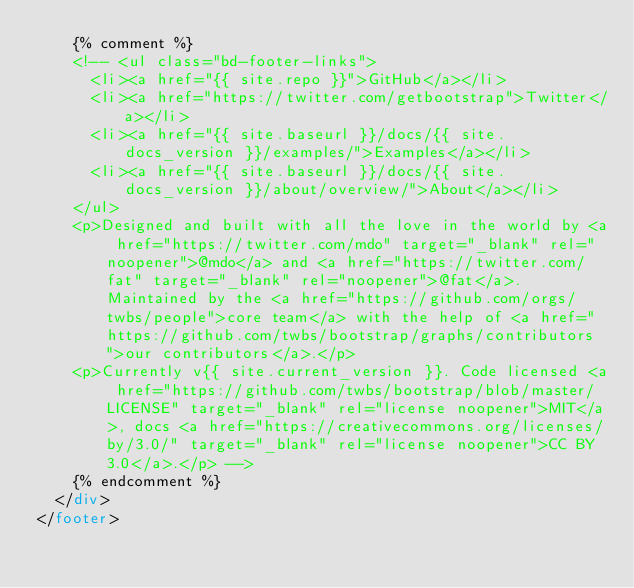<code> <loc_0><loc_0><loc_500><loc_500><_HTML_>    {% comment %}
    <!-- <ul class="bd-footer-links">
      <li><a href="{{ site.repo }}">GitHub</a></li>
      <li><a href="https://twitter.com/getbootstrap">Twitter</a></li>
      <li><a href="{{ site.baseurl }}/docs/{{ site.docs_version }}/examples/">Examples</a></li>
      <li><a href="{{ site.baseurl }}/docs/{{ site.docs_version }}/about/overview/">About</a></li>
    </ul>
    <p>Designed and built with all the love in the world by <a href="https://twitter.com/mdo" target="_blank" rel="noopener">@mdo</a> and <a href="https://twitter.com/fat" target="_blank" rel="noopener">@fat</a>. Maintained by the <a href="https://github.com/orgs/twbs/people">core team</a> with the help of <a href="https://github.com/twbs/bootstrap/graphs/contributors">our contributors</a>.</p>
    <p>Currently v{{ site.current_version }}. Code licensed <a href="https://github.com/twbs/bootstrap/blob/master/LICENSE" target="_blank" rel="license noopener">MIT</a>, docs <a href="https://creativecommons.org/licenses/by/3.0/" target="_blank" rel="license noopener">CC BY 3.0</a>.</p> -->
    {% endcomment %}
  </div>
</footer>
</code> 